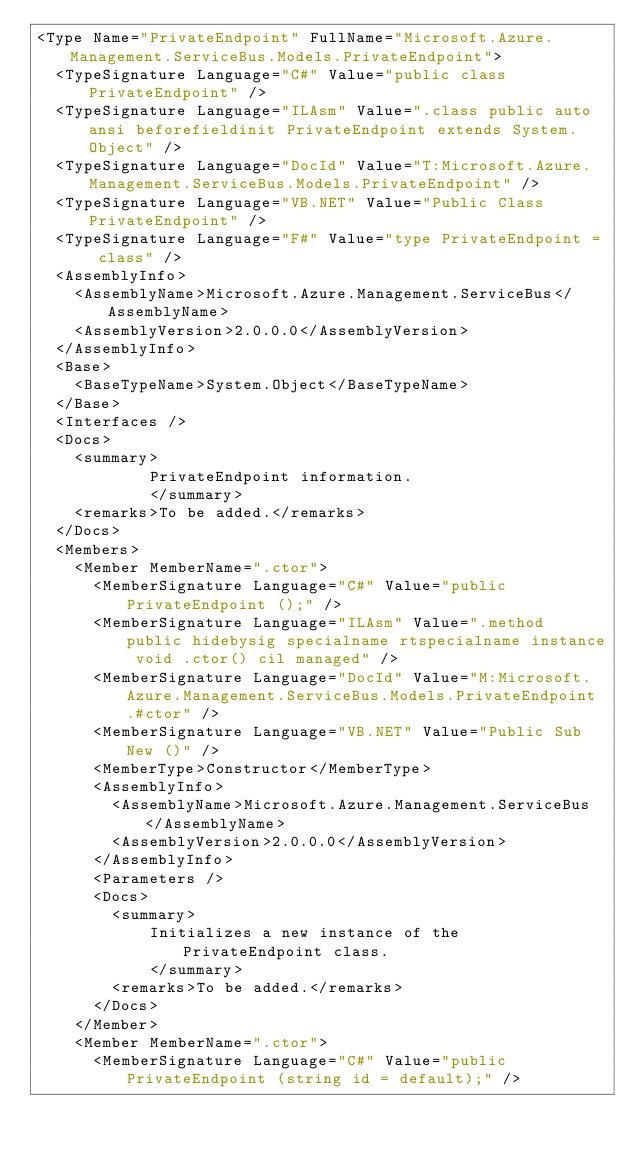<code> <loc_0><loc_0><loc_500><loc_500><_XML_><Type Name="PrivateEndpoint" FullName="Microsoft.Azure.Management.ServiceBus.Models.PrivateEndpoint">
  <TypeSignature Language="C#" Value="public class PrivateEndpoint" />
  <TypeSignature Language="ILAsm" Value=".class public auto ansi beforefieldinit PrivateEndpoint extends System.Object" />
  <TypeSignature Language="DocId" Value="T:Microsoft.Azure.Management.ServiceBus.Models.PrivateEndpoint" />
  <TypeSignature Language="VB.NET" Value="Public Class PrivateEndpoint" />
  <TypeSignature Language="F#" Value="type PrivateEndpoint = class" />
  <AssemblyInfo>
    <AssemblyName>Microsoft.Azure.Management.ServiceBus</AssemblyName>
    <AssemblyVersion>2.0.0.0</AssemblyVersion>
  </AssemblyInfo>
  <Base>
    <BaseTypeName>System.Object</BaseTypeName>
  </Base>
  <Interfaces />
  <Docs>
    <summary>
            PrivateEndpoint information.
            </summary>
    <remarks>To be added.</remarks>
  </Docs>
  <Members>
    <Member MemberName=".ctor">
      <MemberSignature Language="C#" Value="public PrivateEndpoint ();" />
      <MemberSignature Language="ILAsm" Value=".method public hidebysig specialname rtspecialname instance void .ctor() cil managed" />
      <MemberSignature Language="DocId" Value="M:Microsoft.Azure.Management.ServiceBus.Models.PrivateEndpoint.#ctor" />
      <MemberSignature Language="VB.NET" Value="Public Sub New ()" />
      <MemberType>Constructor</MemberType>
      <AssemblyInfo>
        <AssemblyName>Microsoft.Azure.Management.ServiceBus</AssemblyName>
        <AssemblyVersion>2.0.0.0</AssemblyVersion>
      </AssemblyInfo>
      <Parameters />
      <Docs>
        <summary>
            Initializes a new instance of the PrivateEndpoint class.
            </summary>
        <remarks>To be added.</remarks>
      </Docs>
    </Member>
    <Member MemberName=".ctor">
      <MemberSignature Language="C#" Value="public PrivateEndpoint (string id = default);" /></code> 